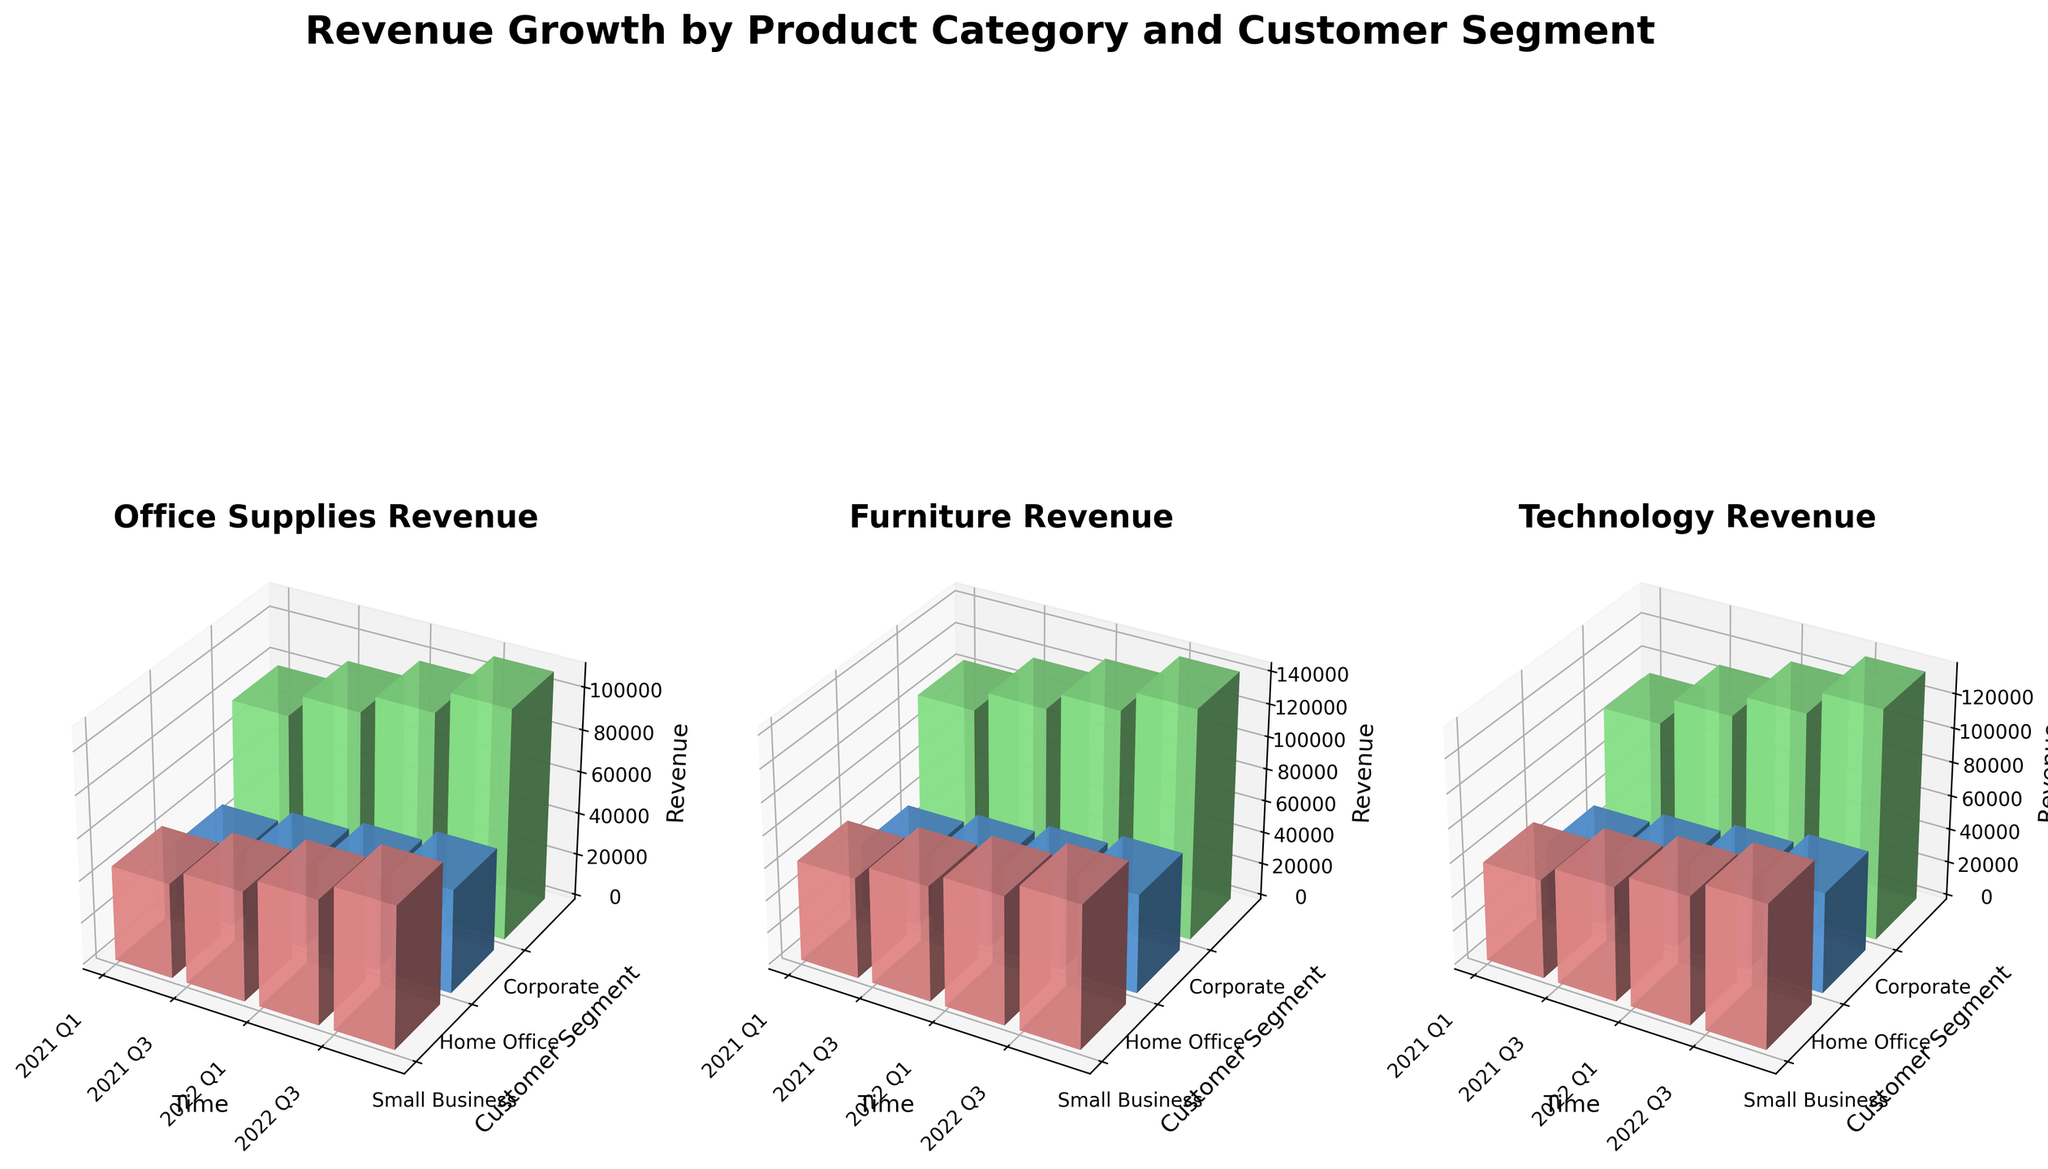Which product category shows the highest revenue growth over time among all customer segments? To determine the category with the highest revenue growth, compare the vertical heights of the bars across each subplot (Office Supplies, Furniture, Technology) from left to right. Technology shows the highest increments in bar heights, indicating its highest revenue growth.
Answer: Technology Which customer segment consistently shows the highest revenue within the Office Supplies category? Analyze the heights of the bars within the Office Supplies subplot for each customer segment. The Corporate segment consistently has the highest bars, indicating the highest revenue.
Answer: Corporate How does the revenue for Small Business in Furniture change from 2021 Q1 to 2022 Q3? Focus on the Furniture subplot and specifically on the bars representing Small Business. The revenue increases from 62000 in 2021 Q1 to 88000 in 2022 Q3.
Answer: Increased from 62000 to 88000 Which customer segment in the Technology category showed the least increase in revenue from 2021 Q1 to 2022 Q3? For the Technology subplot, compare the height differences of the revenue bars for each segment from 2021 Q1 to 2022 Q3. Home Office has the least increase in bar height.
Answer: Home Office What is the average revenue for Corporate in the Furniture category across all displayed periods? Add the revenue figures for the Corporate segment in the Furniture category across all quarters and divide by the number of quarters: (105000 + 118000 + 129000 + 142000)/4
Answer: 123500 Which quarter shows the highest overall revenue across all product categories and customer segments? Compare the total height of all bars combined for each quarter. 2022 Q3 shows the highest aggregate bar heights across all categories and segments.
Answer: 2022 Q3 In which customer segment did the Office Supplies and Technology categories show a significant increase between 2021 Q1 and 2022 Q3? For Office Supplies and Technology subplots, compare the bar heights for the same customer segment between 2021 Q1 and 2022 Q3. Both categories show a significant increase for Small Business segment.
Answer: Small Business Which product category had the most uniform revenue distribution across all customer segments in 2022 Q3? In 2022 Q3, look at the relative evenness in bar heights across the three customer segments (Small Business, Home Office, Corporate) for each category. The Office Supplies category has the most uniform distribution.
Answer: Office Supplies 